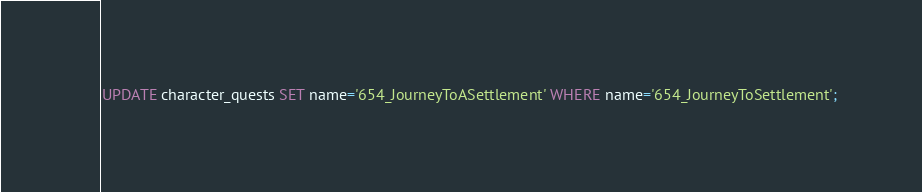<code> <loc_0><loc_0><loc_500><loc_500><_SQL_>UPDATE character_quests SET name='654_JourneyToASettlement' WHERE name='654_JourneyToSettlement';</code> 